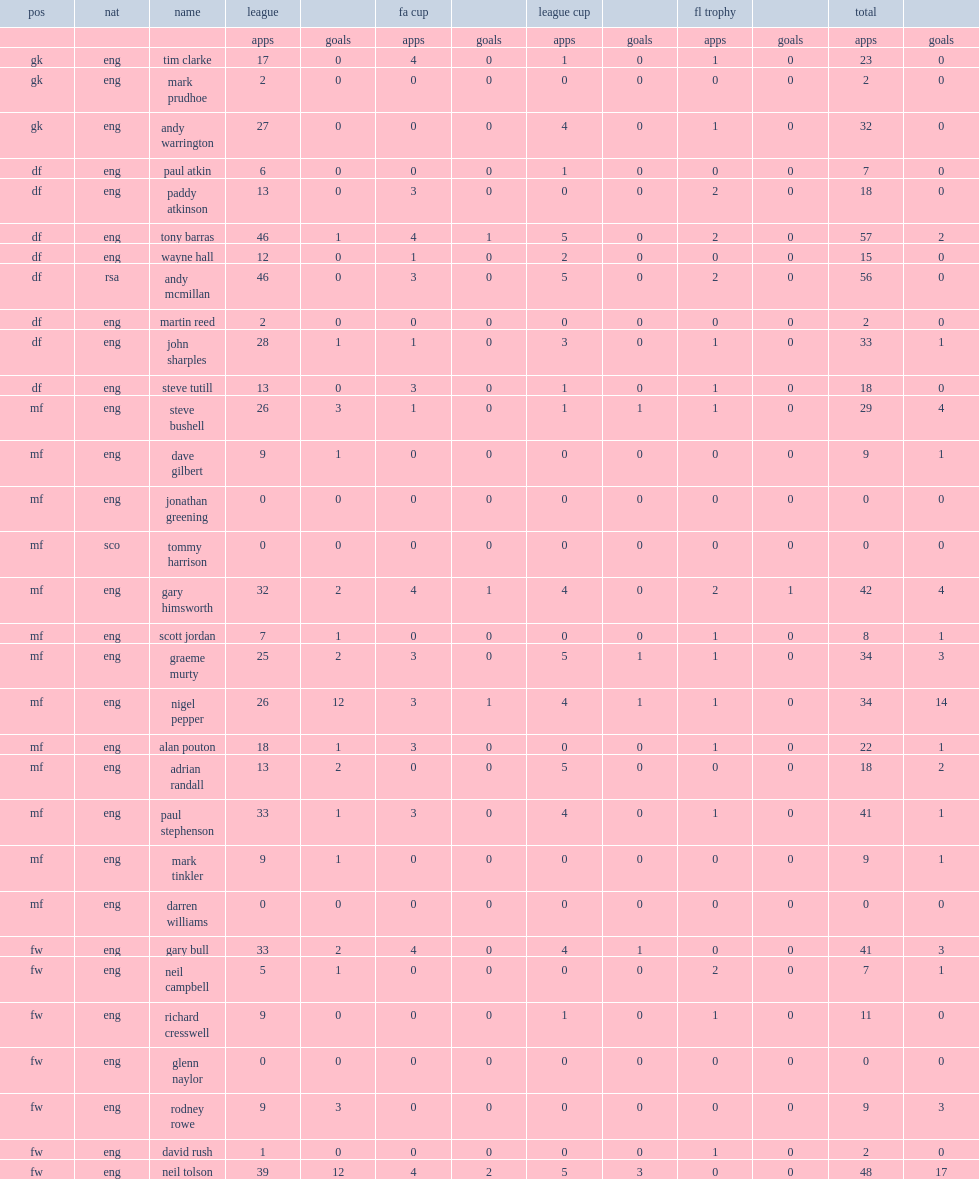What the matches did the york city f.c. appear in? Fa cup league cup fl trophy. 